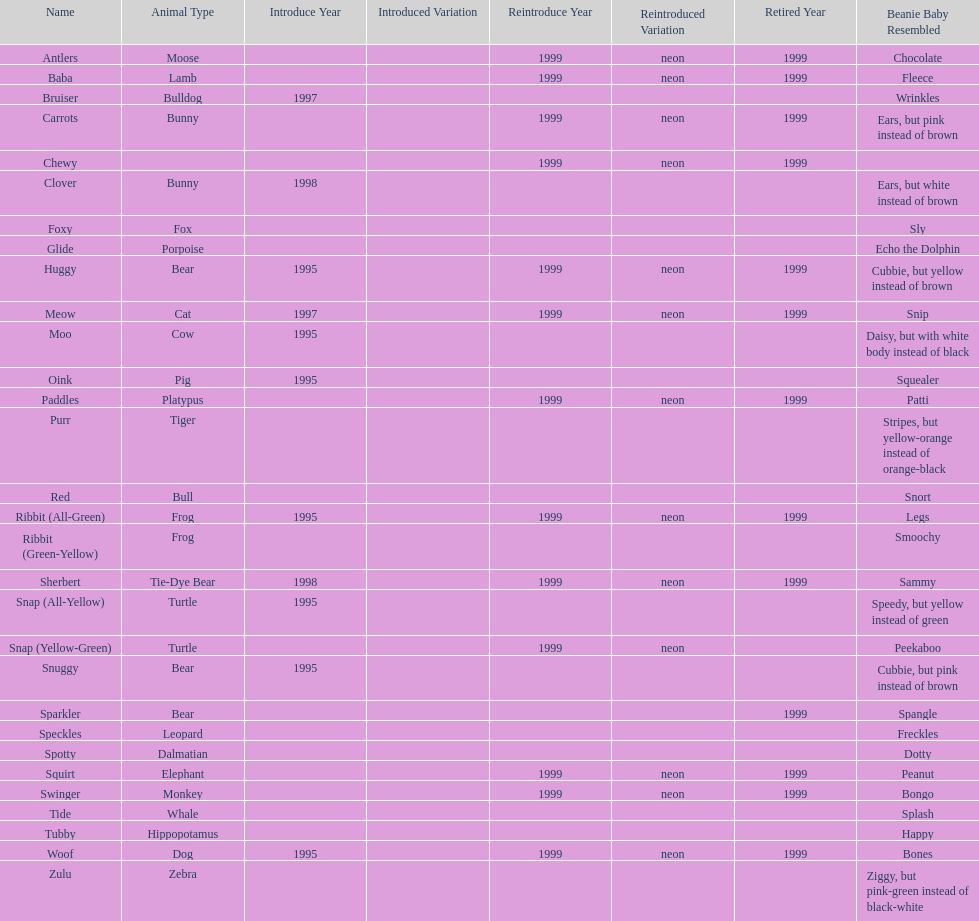What is the total number of pillow pals that were reintroduced as a neon variety? 13. 